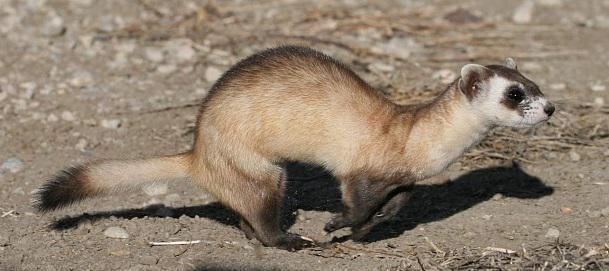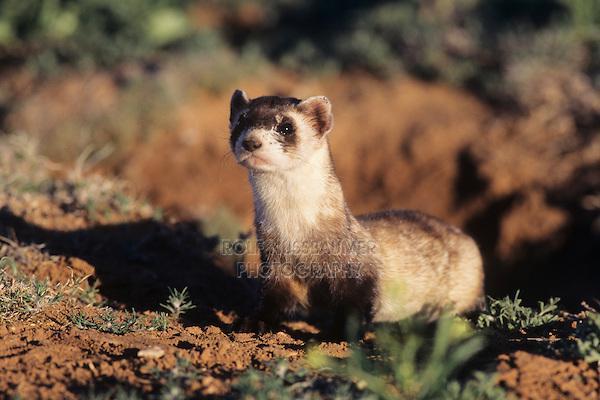The first image is the image on the left, the second image is the image on the right. Assess this claim about the two images: "All bodies of the animals pictured are facing right.". Correct or not? Answer yes or no. No. The first image is the image on the left, the second image is the image on the right. Considering the images on both sides, is "One image shows a ferret with raised head, and body turned to the left." valid? Answer yes or no. Yes. 